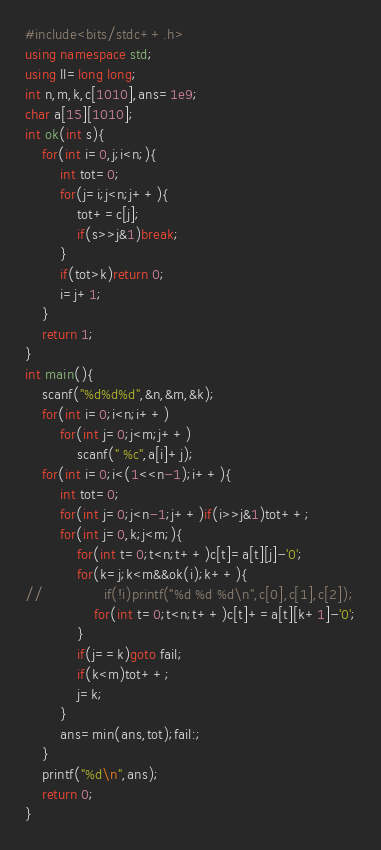<code> <loc_0><loc_0><loc_500><loc_500><_C++_>#include<bits/stdc++.h>
using namespace std;
using ll=long long;
int n,m,k,c[1010],ans=1e9;
char a[15][1010];
int ok(int s){
	for(int i=0,j;i<n;){
		int tot=0;
		for(j=i;j<n;j++){
			tot+=c[j];
			if(s>>j&1)break;
		}
		if(tot>k)return 0;
		i=j+1;
	}
	return 1;
}
int main(){
	scanf("%d%d%d",&n,&m,&k);
	for(int i=0;i<n;i++)
		for(int j=0;j<m;j++)
			scanf(" %c",a[i]+j);
	for(int i=0;i<(1<<n-1);i++){
		int tot=0;
		for(int j=0;j<n-1;j++)if(i>>j&1)tot++;
		for(int j=0,k;j<m;){
			for(int t=0;t<n;t++)c[t]=a[t][j]-'0';
			for(k=j;k<m&&ok(i);k++){
//				if(!i)printf("%d %d %d\n",c[0],c[1],c[2]);
				for(int t=0;t<n;t++)c[t]+=a[t][k+1]-'0';
			}
			if(j==k)goto fail;
			if(k<m)tot++;
			j=k;
		}
		ans=min(ans,tot);fail:;
	}
	printf("%d\n",ans);
	return 0;
}</code> 